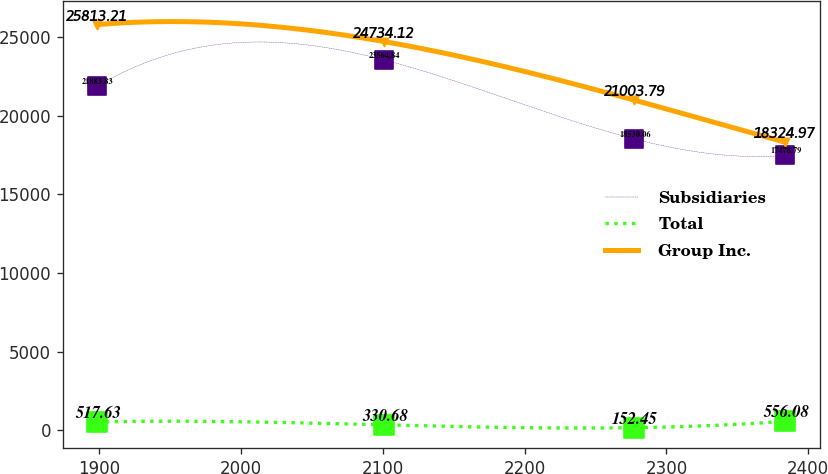<chart> <loc_0><loc_0><loc_500><loc_500><line_chart><ecel><fcel>Subsidiaries<fcel>Total<fcel>Group Inc.<nl><fcel>1898.51<fcel>21883.8<fcel>517.63<fcel>25813.2<nl><fcel>2100.83<fcel>23564.8<fcel>330.68<fcel>24734.1<nl><fcel>2277.38<fcel>18530.1<fcel>152.45<fcel>21003.8<nl><fcel>2383.75<fcel>17478.8<fcel>556.08<fcel>18325<nl></chart> 